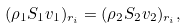Convert formula to latex. <formula><loc_0><loc_0><loc_500><loc_500>( \rho _ { 1 } S _ { 1 } v _ { 1 } ) _ { r _ { i } } = ( \rho _ { 2 } S _ { 2 } v _ { 2 } ) _ { r _ { i } } ,</formula> 